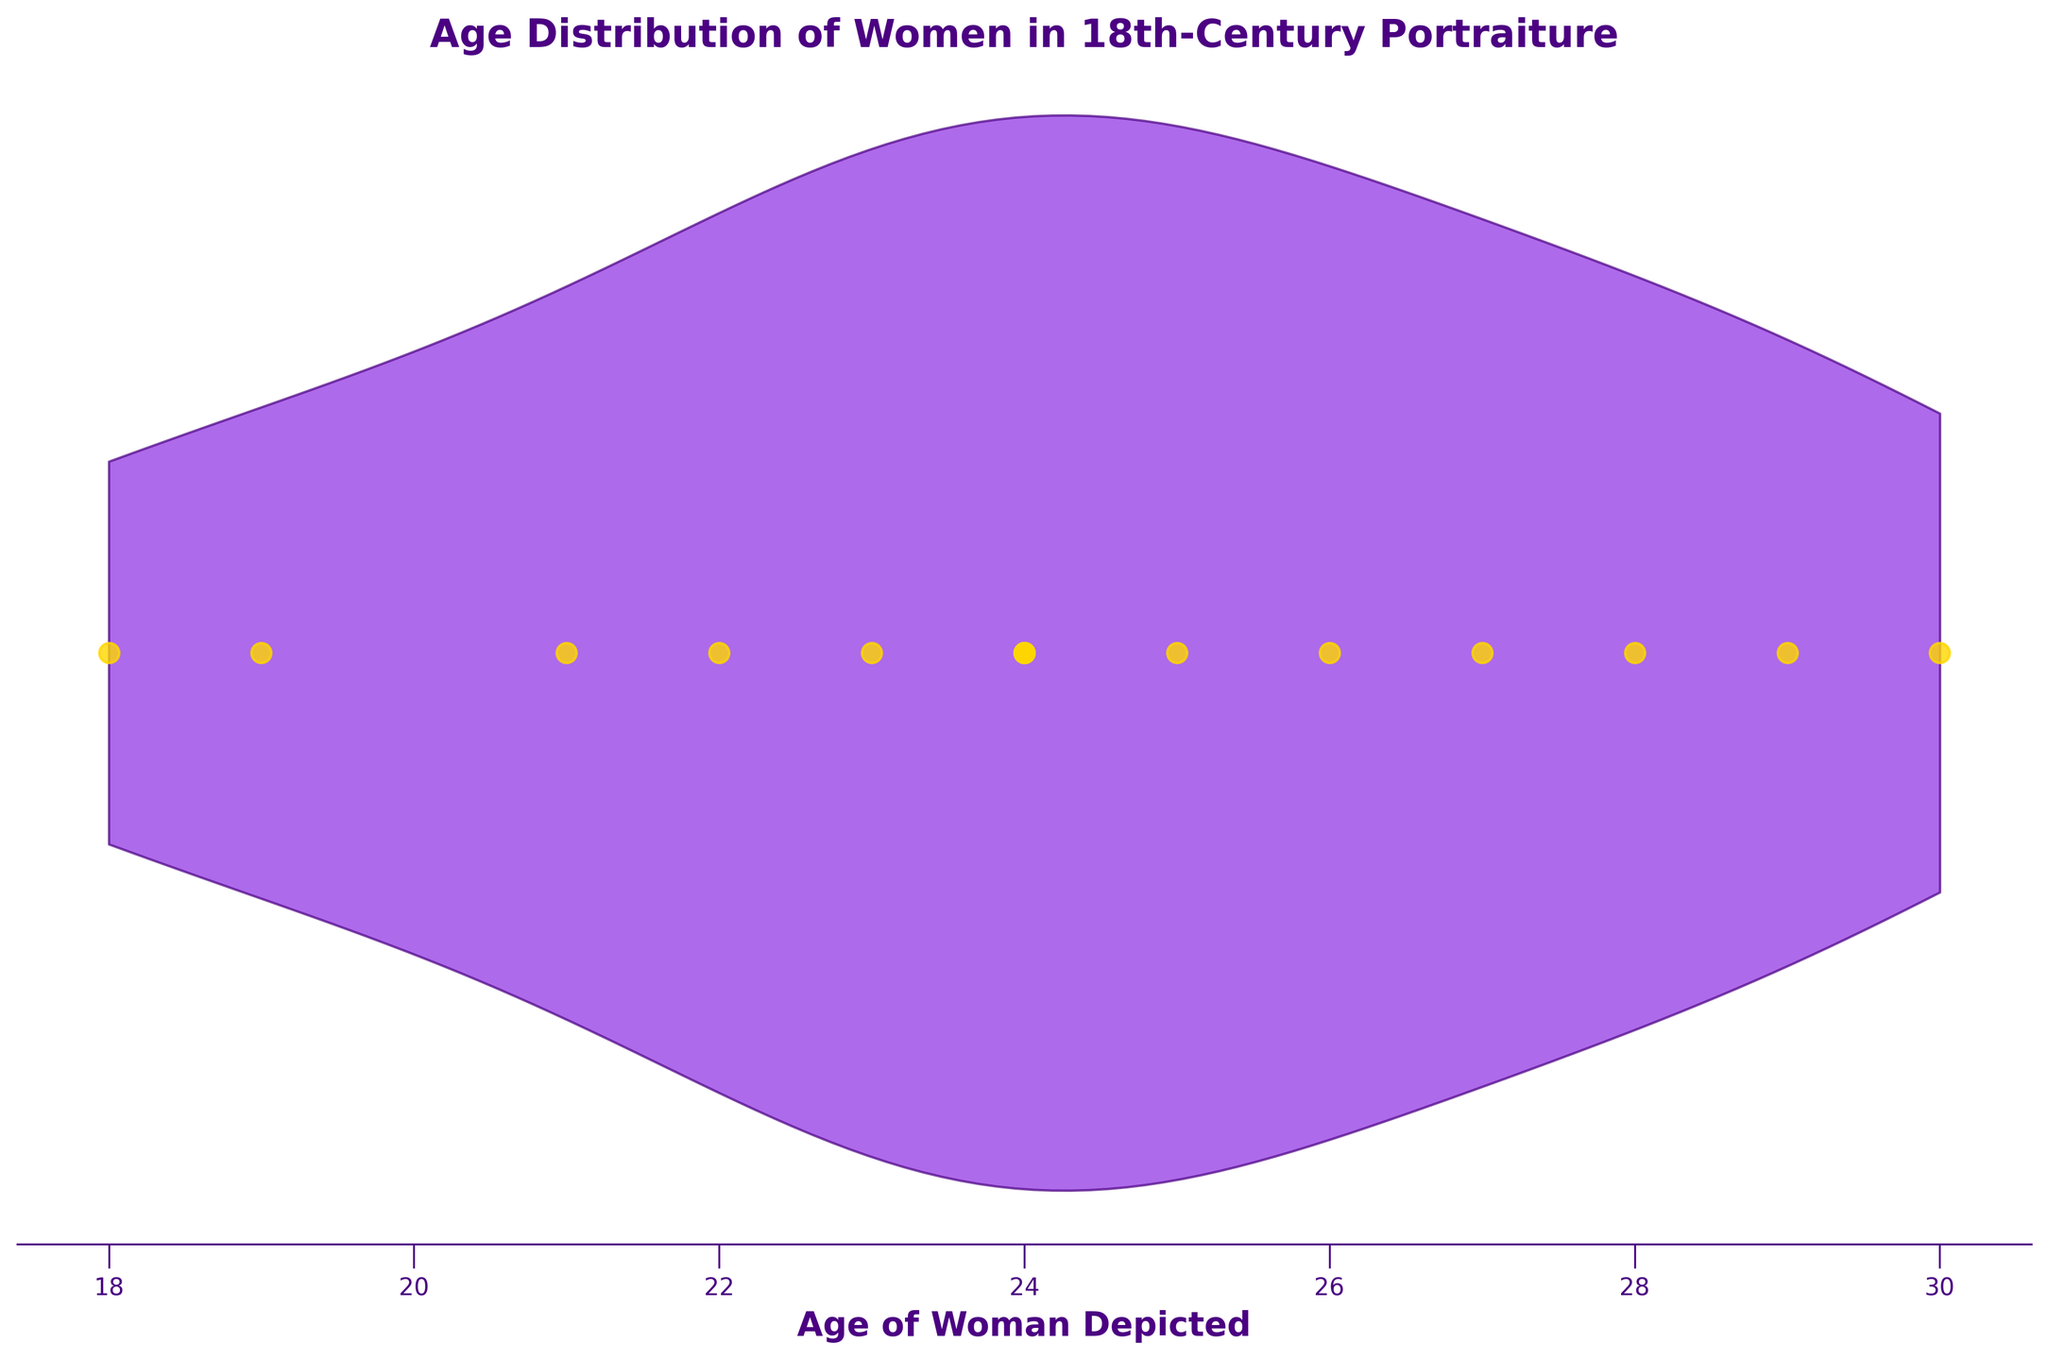What is the title of the figure? The title is usually located at the top of the figure, which is an easy element to spot.
Answer: Age Distribution of Women in 18th-Century Portraiture How many women have been portrayed in the portraits? Each yellow dot represents a woman depicted in the portraits. Count the dots to find the answer.
Answer: 14 What is the range of ages depicted in the portraiture? The range is found by identifying the minimum and maximum ages shown on the x-axis. Here, ages span from 18 to 30.
Answer: 18 to 30 What age is shown most frequently in the dataset? The area where the violin plot is widest indicates the mode, or most frequently occurring age. We can see that the violin plot is widest around the ages 24 and 25.
Answer: 24 and 25 How does the number of women depicted at age 24 compare to those at age 26? Look at the scatter plot overlay to compare the number of yellow dots at ages 24 and 26. Age 24 has more dots than age 26.
Answer: More at age 24 What is the median age of women depicted in the portraits? The median is the middle value when data points are ordered. Arrange the 14 ages (18, 19, 21, 22, 23, 24, 24, 24, 25, 26, 27, 28, 29, 30) to find the median, which falls between the 7th and 8th values. This is the average of 24 and 24.
Answer: 24 What is the average age of women depicted in these portraits? To find the mean, sum the ages and divide by the number of data points. Sum = 346, number of points = 14, so average = 346 / 14.
Answer: 24.71 Which age appears to be an outlier, if any? Identify any ages that are far away from the main cluster in the violin plot or scatter plot. Age 18 is relatively isolated from the bulk of data.
Answer: 18 Is there a visible trend in the age distribution? Looking at the violin plot, assess if there's a concentration of ages within a particular range or if the distribution is fairly uniform. There is a concentration around ages 24-25.
Answer: Concentration around 24-25 How do the youngest and oldest ages compare in terms of their frequency of depiction? Check the scatter plot and whiskers of the violin plot. Ages 18 and 30 are depicted but are not the most frequent. The majority are around mid-20s.
Answer: Both are less frequent 